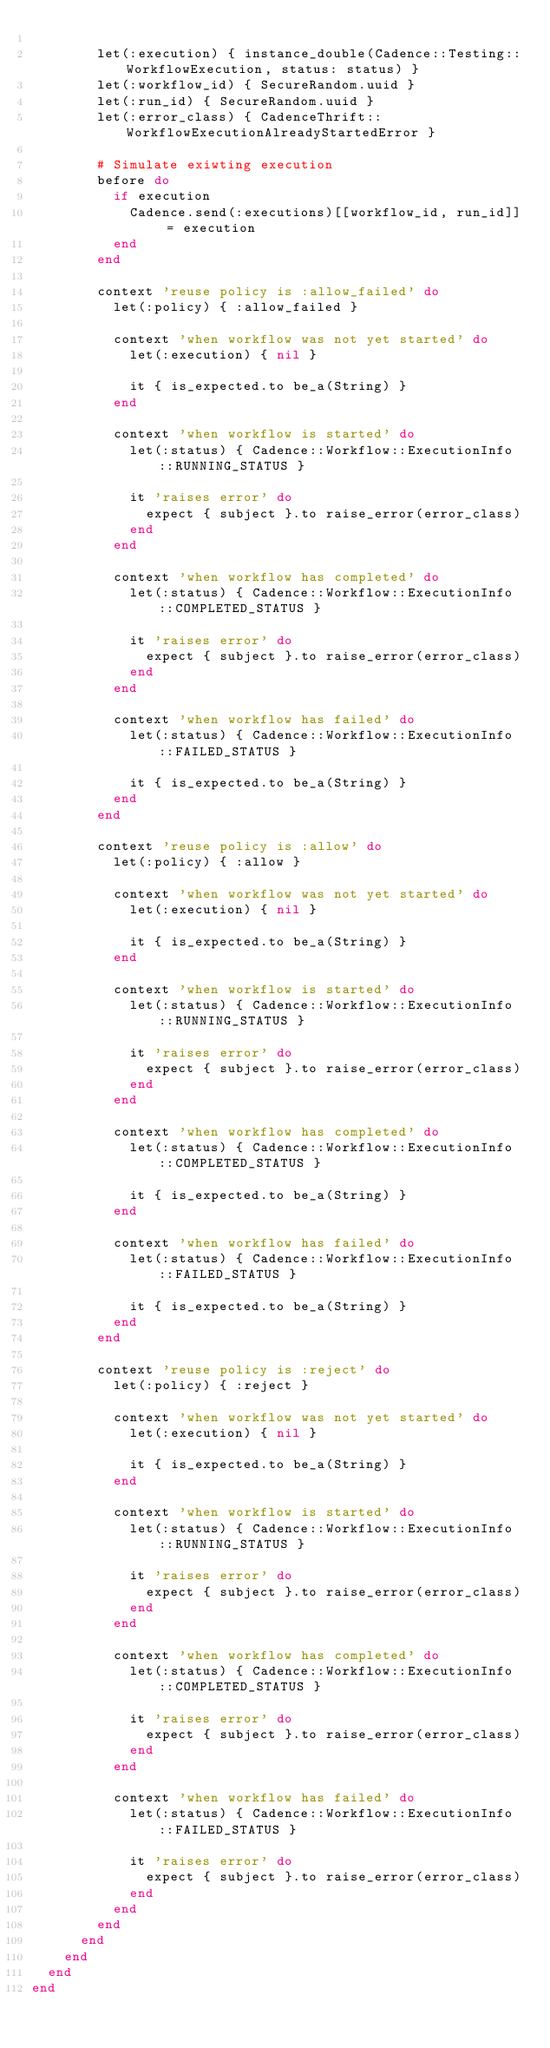Convert code to text. <code><loc_0><loc_0><loc_500><loc_500><_Ruby_>
        let(:execution) { instance_double(Cadence::Testing::WorkflowExecution, status: status) }
        let(:workflow_id) { SecureRandom.uuid }
        let(:run_id) { SecureRandom.uuid }
        let(:error_class) { CadenceThrift::WorkflowExecutionAlreadyStartedError }

        # Simulate exiwting execution
        before do
          if execution
            Cadence.send(:executions)[[workflow_id, run_id]] = execution
          end
        end

        context 'reuse policy is :allow_failed' do
          let(:policy) { :allow_failed }

          context 'when workflow was not yet started' do
            let(:execution) { nil }

            it { is_expected.to be_a(String) }
          end

          context 'when workflow is started' do
            let(:status) { Cadence::Workflow::ExecutionInfo::RUNNING_STATUS }

            it 'raises error' do
              expect { subject }.to raise_error(error_class)
            end
          end

          context 'when workflow has completed' do
            let(:status) { Cadence::Workflow::ExecutionInfo::COMPLETED_STATUS }

            it 'raises error' do
              expect { subject }.to raise_error(error_class)
            end
          end

          context 'when workflow has failed' do
            let(:status) { Cadence::Workflow::ExecutionInfo::FAILED_STATUS }

            it { is_expected.to be_a(String) }
          end
        end

        context 'reuse policy is :allow' do
          let(:policy) { :allow }

          context 'when workflow was not yet started' do
            let(:execution) { nil }

            it { is_expected.to be_a(String) }
          end

          context 'when workflow is started' do
            let(:status) { Cadence::Workflow::ExecutionInfo::RUNNING_STATUS }

            it 'raises error' do
              expect { subject }.to raise_error(error_class)
            end
          end

          context 'when workflow has completed' do
            let(:status) { Cadence::Workflow::ExecutionInfo::COMPLETED_STATUS }

            it { is_expected.to be_a(String) }
          end

          context 'when workflow has failed' do
            let(:status) { Cadence::Workflow::ExecutionInfo::FAILED_STATUS }

            it { is_expected.to be_a(String) }
          end
        end

        context 'reuse policy is :reject' do
          let(:policy) { :reject }

          context 'when workflow was not yet started' do
            let(:execution) { nil }

            it { is_expected.to be_a(String) }
          end

          context 'when workflow is started' do
            let(:status) { Cadence::Workflow::ExecutionInfo::RUNNING_STATUS }

            it 'raises error' do
              expect { subject }.to raise_error(error_class)
            end
          end

          context 'when workflow has completed' do
            let(:status) { Cadence::Workflow::ExecutionInfo::COMPLETED_STATUS }

            it 'raises error' do
              expect { subject }.to raise_error(error_class)
            end
          end

          context 'when workflow has failed' do
            let(:status) { Cadence::Workflow::ExecutionInfo::FAILED_STATUS }

            it 'raises error' do
              expect { subject }.to raise_error(error_class)
            end
          end
        end
      end
    end
  end
end
</code> 